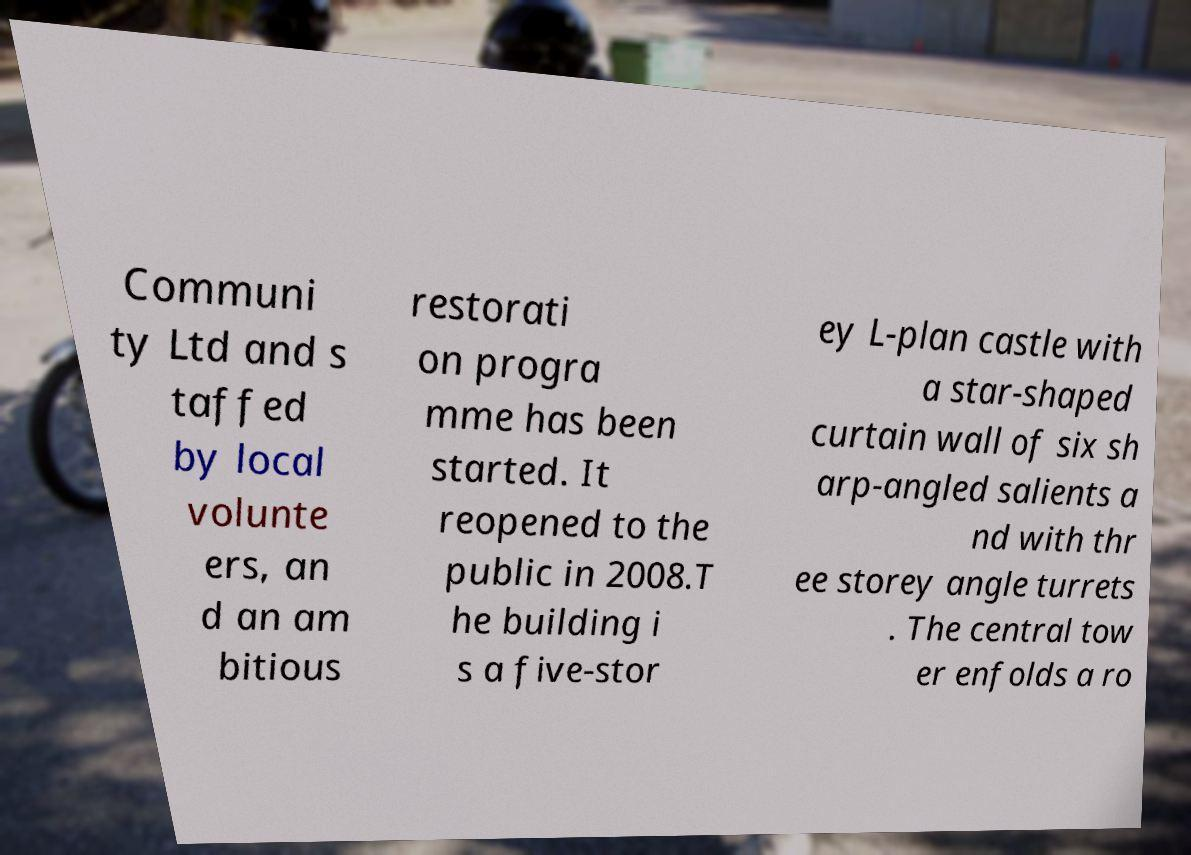Can you accurately transcribe the text from the provided image for me? Communi ty Ltd and s taffed by local volunte ers, an d an am bitious restorati on progra mme has been started. It reopened to the public in 2008.T he building i s a five-stor ey L-plan castle with a star-shaped curtain wall of six sh arp-angled salients a nd with thr ee storey angle turrets . The central tow er enfolds a ro 